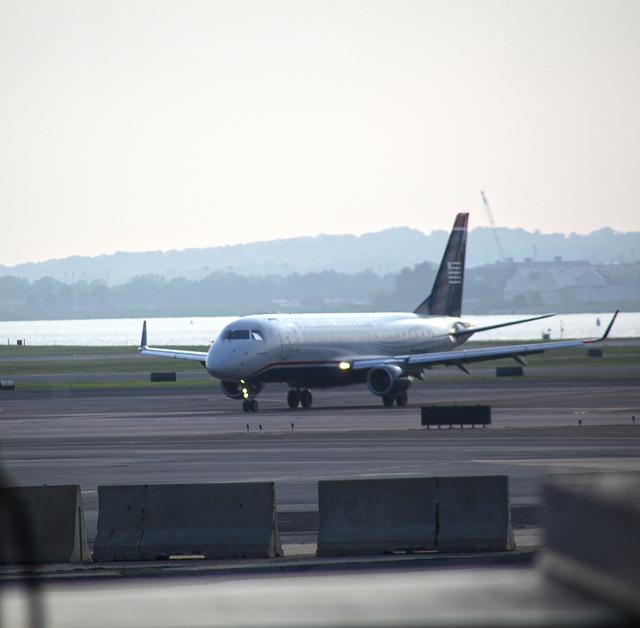How many planes are in the photo?
Keep it brief. 1. Is the plane on the runway?
Be succinct. Yes. Is it a cloudy day?
Answer briefly. Yes. 